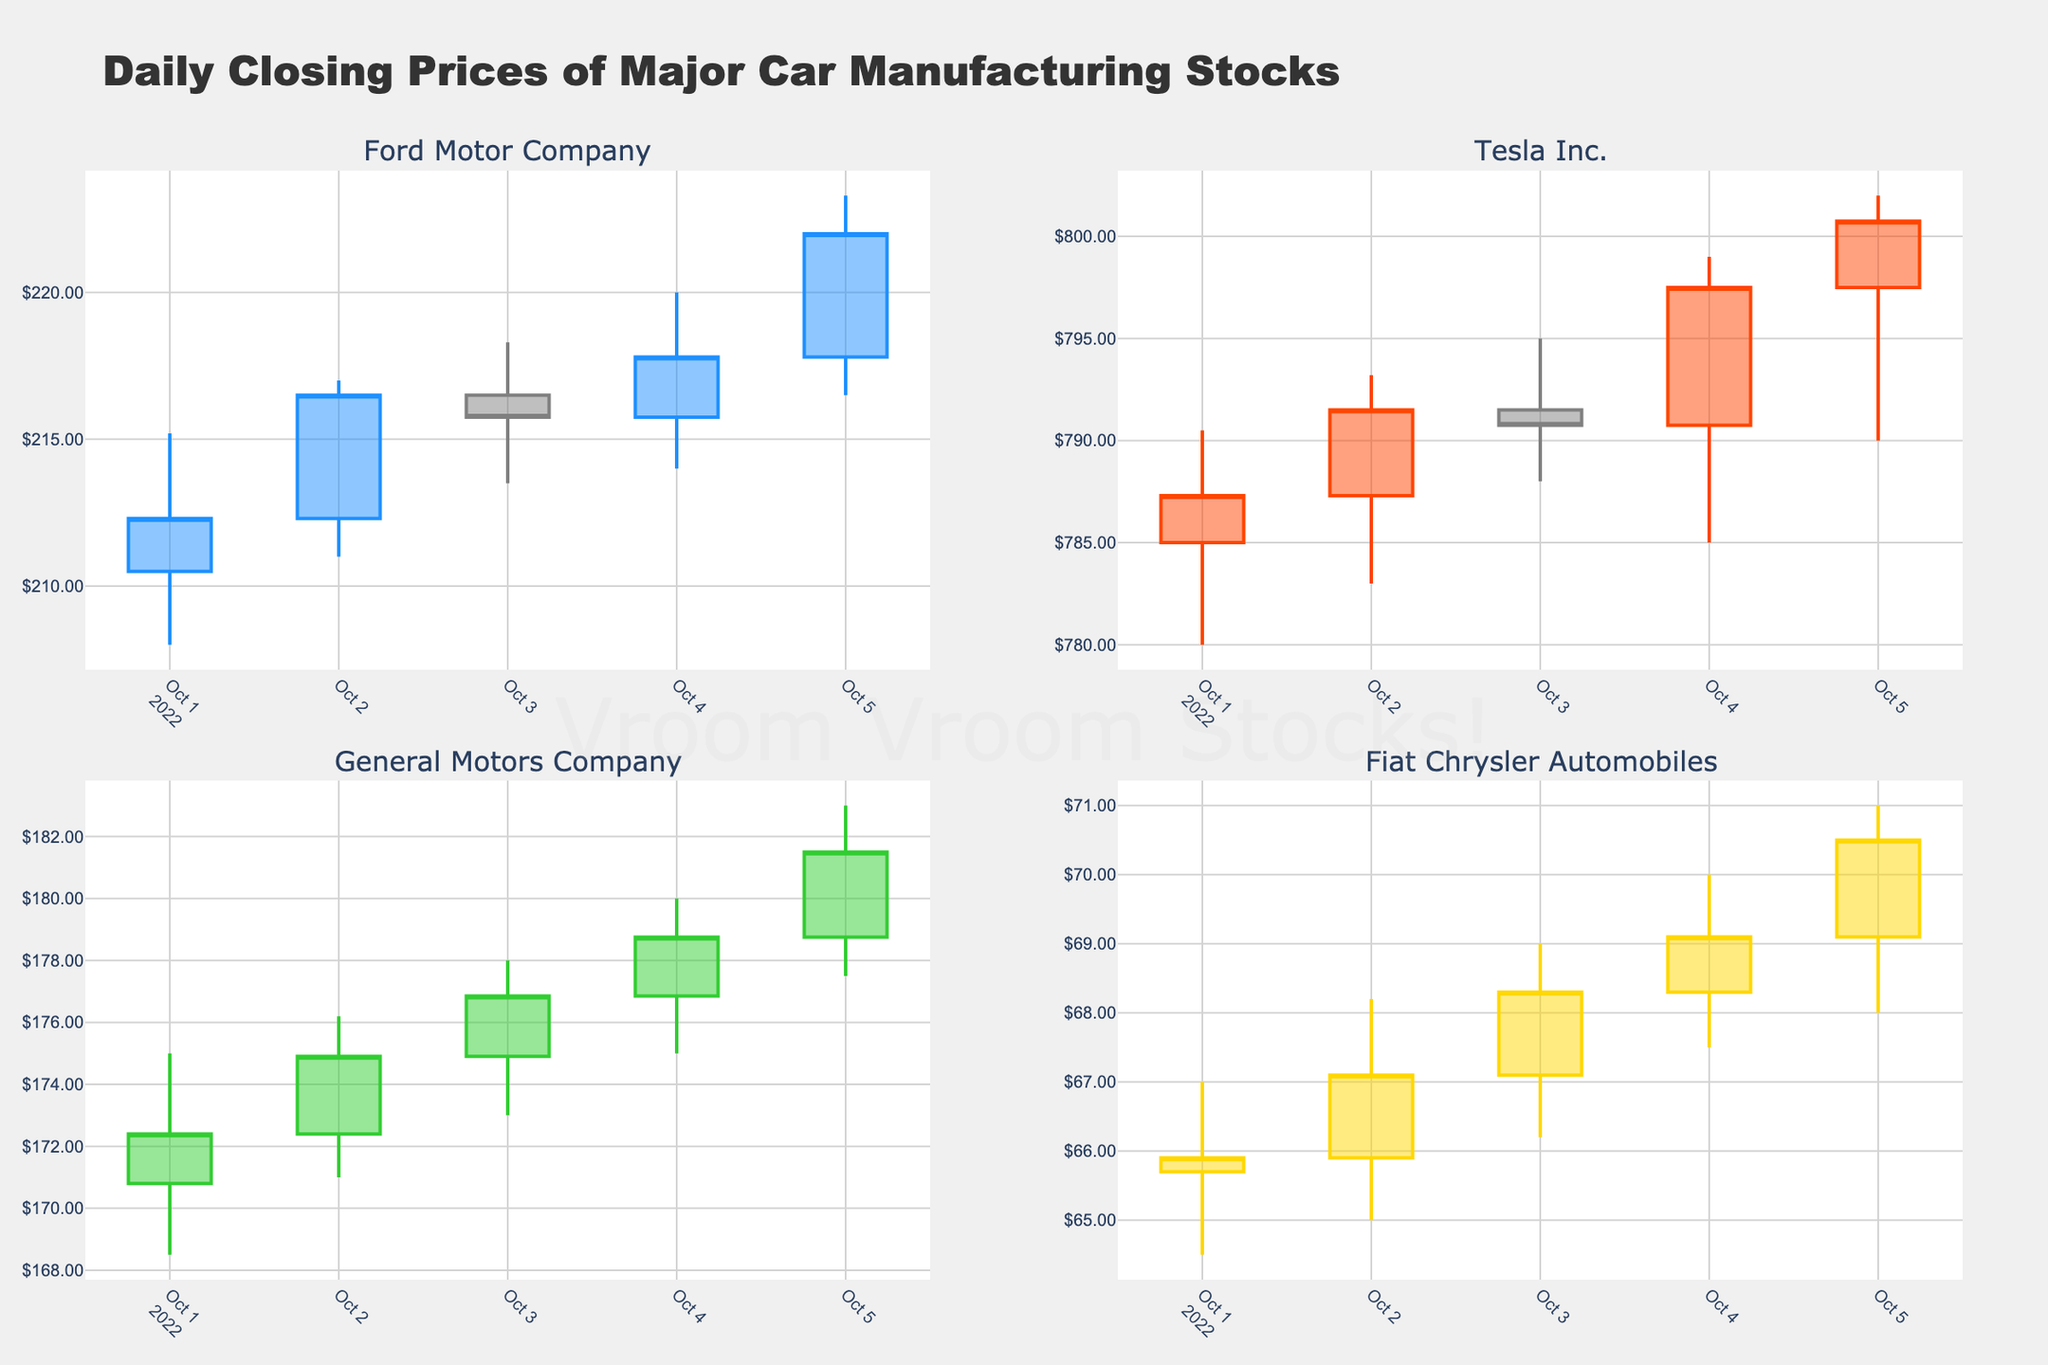what is the title of the figure? The title is usually located at the top center of the plot. It helps in understanding the overall subject of the plot. According to the provided code, the title set for the figure is "Daily Closing Prices of Major Car Manufacturing Stocks".
Answer: Daily Closing Prices of Major Car Manufacturing Stocks How many different stocks are represented in the plot? The code creates subplots for each unique stock in the dataset. By looking at the subplot titles, you can identify how many different stocks are shown. According to the subplot_titles parameter, there are 4 unique stocks represented in the plot.
Answer: Four Which stock had the highest closing price on October 5th, 2022? To answer this, look at the candlestick data points for each subplot corresponding to October 5th, 2022. Compare the closing prices (highlighted by the candlesticks). Tesla Inc. has the highest closing price at $800.75.
Answer: Tesla Inc How many subplots are present in the figure? The figure layout includes subplots arranged in a 2x2 grid, as indicated by the rows and cols variables in the make_subplots function, resulting in four subplots.
Answer: Four Which stock showed the greatest increase in closing price from October 1st to October 5th, 2022? To find this, calculate the difference between the closing prices on October 1st and October 5th for each stock, then compare these differences. Ford Motor Company increased from $212.30 to $222.00, Tesla Inc. from $787.30 to $800.75, General Motors Company from $172.40 to $181.50, and Fiat Chrysler Automobiles from $65.90 to $70.50. The largest increase is by Tesla Inc., which rose by $13.45.
Answer: Tesla Inc Which stock appears the most volatile based on the visible candlestick patterns? Volatility can be judged by the length and fluctuation of the candlesticks. The stock with the most extreme highs and lows within each day suggests higher volatility. Tesla Inc. with its wider range of high and low prices in the daily candles indicates it is the most volatile.
Answer: Tesla Inc What is the pattern of closing prices for Fiat Chrysler Automobiles over the five days represented? Observe the closing prices for Fiat Chrysler Automobiles in its subplot. Starting from October 1st to October 5th, the prices are $65.90, $67.10, $68.30, $69.10, and finally $70.50. This shows a consistent upward trend over these days.
Answer: Increasing 